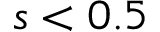Convert formula to latex. <formula><loc_0><loc_0><loc_500><loc_500>s < 0 . 5</formula> 